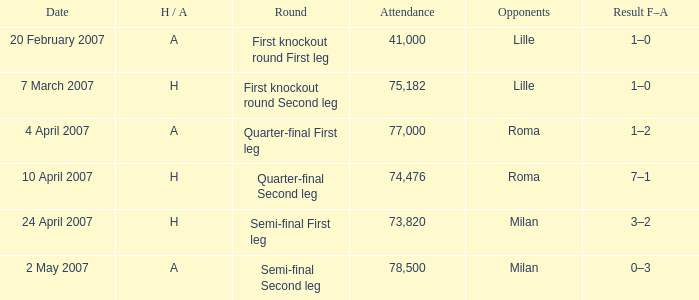Can you parse all the data within this table? {'header': ['Date', 'H / A', 'Round', 'Attendance', 'Opponents', 'Result F–A'], 'rows': [['20 February 2007', 'A', 'First knockout round First leg', '41,000', 'Lille', '1–0'], ['7 March 2007', 'H', 'First knockout round Second leg', '75,182', 'Lille', '1–0'], ['4 April 2007', 'A', 'Quarter-final First leg', '77,000', 'Roma', '1–2'], ['10 April 2007', 'H', 'Quarter-final Second leg', '74,476', 'Roma', '7–1'], ['24 April 2007', 'H', 'Semi-final First leg', '73,820', 'Milan', '3–2'], ['2 May 2007', 'A', 'Semi-final Second leg', '78,500', 'Milan', '0–3']]} Which round has Attendance larger than 41,000, a H/A of A, and a Result F–A of 1–2? Quarter-final First leg. 